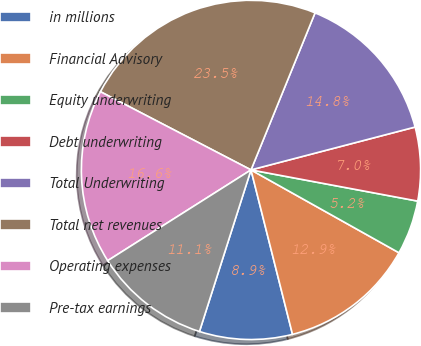<chart> <loc_0><loc_0><loc_500><loc_500><pie_chart><fcel>in millions<fcel>Financial Advisory<fcel>Equity underwriting<fcel>Debt underwriting<fcel>Total Underwriting<fcel>Total net revenues<fcel>Operating expenses<fcel>Pre-tax earnings<nl><fcel>8.85%<fcel>12.94%<fcel>5.18%<fcel>7.01%<fcel>14.77%<fcel>23.54%<fcel>16.61%<fcel>11.1%<nl></chart> 